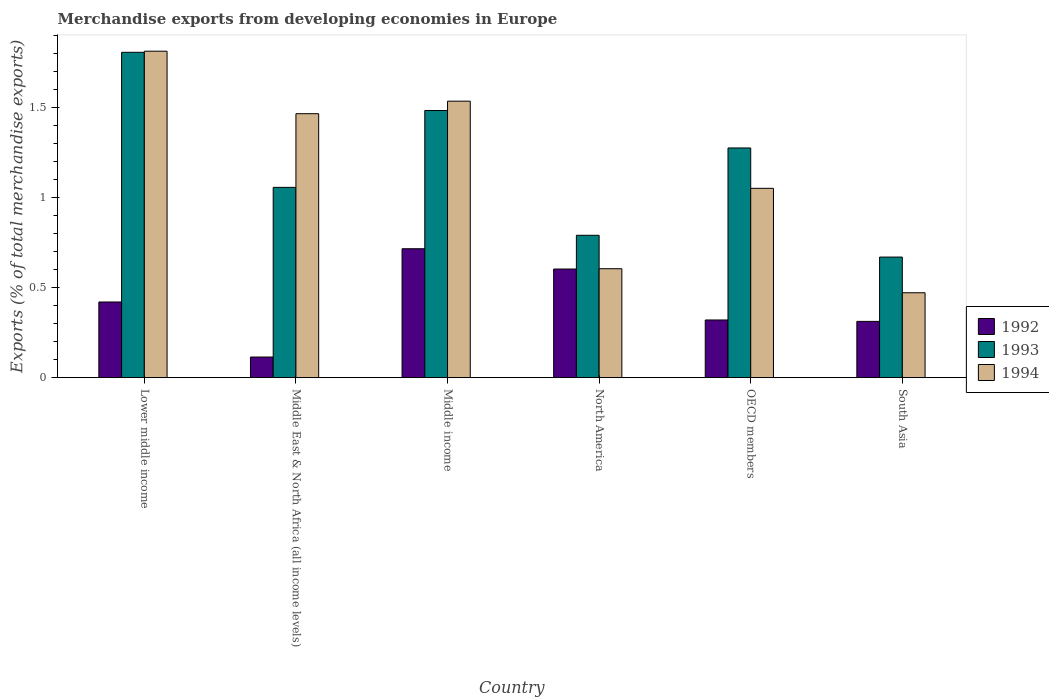How many different coloured bars are there?
Provide a short and direct response. 3. How many groups of bars are there?
Provide a succinct answer. 6. Are the number of bars on each tick of the X-axis equal?
Give a very brief answer. Yes. What is the percentage of total merchandise exports in 1992 in North America?
Make the answer very short. 0.6. Across all countries, what is the maximum percentage of total merchandise exports in 1993?
Ensure brevity in your answer.  1.81. Across all countries, what is the minimum percentage of total merchandise exports in 1993?
Provide a succinct answer. 0.67. In which country was the percentage of total merchandise exports in 1992 maximum?
Provide a short and direct response. Middle income. In which country was the percentage of total merchandise exports in 1992 minimum?
Your answer should be very brief. Middle East & North Africa (all income levels). What is the total percentage of total merchandise exports in 1993 in the graph?
Your response must be concise. 7.09. What is the difference between the percentage of total merchandise exports in 1994 in Lower middle income and that in South Asia?
Make the answer very short. 1.34. What is the difference between the percentage of total merchandise exports in 1993 in North America and the percentage of total merchandise exports in 1994 in OECD members?
Offer a terse response. -0.26. What is the average percentage of total merchandise exports in 1993 per country?
Your answer should be compact. 1.18. What is the difference between the percentage of total merchandise exports of/in 1994 and percentage of total merchandise exports of/in 1993 in OECD members?
Your answer should be compact. -0.22. In how many countries, is the percentage of total merchandise exports in 1992 greater than 1 %?
Your answer should be very brief. 0. What is the ratio of the percentage of total merchandise exports in 1994 in North America to that in OECD members?
Ensure brevity in your answer.  0.58. Is the difference between the percentage of total merchandise exports in 1994 in OECD members and South Asia greater than the difference between the percentage of total merchandise exports in 1993 in OECD members and South Asia?
Offer a terse response. No. What is the difference between the highest and the second highest percentage of total merchandise exports in 1993?
Offer a very short reply. 0.53. What is the difference between the highest and the lowest percentage of total merchandise exports in 1994?
Offer a terse response. 1.34. Is the sum of the percentage of total merchandise exports in 1992 in Middle East & North Africa (all income levels) and Middle income greater than the maximum percentage of total merchandise exports in 1993 across all countries?
Your answer should be compact. No. What does the 2nd bar from the right in Lower middle income represents?
Give a very brief answer. 1993. Is it the case that in every country, the sum of the percentage of total merchandise exports in 1994 and percentage of total merchandise exports in 1993 is greater than the percentage of total merchandise exports in 1992?
Provide a short and direct response. Yes. Are all the bars in the graph horizontal?
Your answer should be very brief. No. Are the values on the major ticks of Y-axis written in scientific E-notation?
Make the answer very short. No. Does the graph contain any zero values?
Your answer should be compact. No. What is the title of the graph?
Make the answer very short. Merchandise exports from developing economies in Europe. Does "1967" appear as one of the legend labels in the graph?
Give a very brief answer. No. What is the label or title of the Y-axis?
Offer a very short reply. Exports (% of total merchandise exports). What is the Exports (% of total merchandise exports) in 1992 in Lower middle income?
Offer a terse response. 0.42. What is the Exports (% of total merchandise exports) in 1993 in Lower middle income?
Your answer should be compact. 1.81. What is the Exports (% of total merchandise exports) in 1994 in Lower middle income?
Your response must be concise. 1.81. What is the Exports (% of total merchandise exports) of 1992 in Middle East & North Africa (all income levels)?
Offer a terse response. 0.11. What is the Exports (% of total merchandise exports) of 1993 in Middle East & North Africa (all income levels)?
Keep it short and to the point. 1.06. What is the Exports (% of total merchandise exports) in 1994 in Middle East & North Africa (all income levels)?
Provide a succinct answer. 1.47. What is the Exports (% of total merchandise exports) in 1992 in Middle income?
Offer a very short reply. 0.72. What is the Exports (% of total merchandise exports) of 1993 in Middle income?
Keep it short and to the point. 1.48. What is the Exports (% of total merchandise exports) of 1994 in Middle income?
Ensure brevity in your answer.  1.54. What is the Exports (% of total merchandise exports) in 1992 in North America?
Make the answer very short. 0.6. What is the Exports (% of total merchandise exports) in 1993 in North America?
Offer a very short reply. 0.79. What is the Exports (% of total merchandise exports) of 1994 in North America?
Provide a short and direct response. 0.61. What is the Exports (% of total merchandise exports) in 1992 in OECD members?
Give a very brief answer. 0.32. What is the Exports (% of total merchandise exports) of 1993 in OECD members?
Provide a short and direct response. 1.28. What is the Exports (% of total merchandise exports) in 1994 in OECD members?
Provide a short and direct response. 1.05. What is the Exports (% of total merchandise exports) of 1992 in South Asia?
Offer a very short reply. 0.31. What is the Exports (% of total merchandise exports) in 1993 in South Asia?
Your answer should be very brief. 0.67. What is the Exports (% of total merchandise exports) in 1994 in South Asia?
Offer a very short reply. 0.47. Across all countries, what is the maximum Exports (% of total merchandise exports) of 1992?
Make the answer very short. 0.72. Across all countries, what is the maximum Exports (% of total merchandise exports) of 1993?
Provide a short and direct response. 1.81. Across all countries, what is the maximum Exports (% of total merchandise exports) of 1994?
Your answer should be very brief. 1.81. Across all countries, what is the minimum Exports (% of total merchandise exports) in 1992?
Your answer should be compact. 0.11. Across all countries, what is the minimum Exports (% of total merchandise exports) in 1993?
Your answer should be very brief. 0.67. Across all countries, what is the minimum Exports (% of total merchandise exports) in 1994?
Provide a short and direct response. 0.47. What is the total Exports (% of total merchandise exports) of 1992 in the graph?
Provide a short and direct response. 2.49. What is the total Exports (% of total merchandise exports) of 1993 in the graph?
Offer a very short reply. 7.09. What is the total Exports (% of total merchandise exports) of 1994 in the graph?
Provide a short and direct response. 6.95. What is the difference between the Exports (% of total merchandise exports) of 1992 in Lower middle income and that in Middle East & North Africa (all income levels)?
Offer a very short reply. 0.31. What is the difference between the Exports (% of total merchandise exports) in 1993 in Lower middle income and that in Middle East & North Africa (all income levels)?
Give a very brief answer. 0.75. What is the difference between the Exports (% of total merchandise exports) of 1994 in Lower middle income and that in Middle East & North Africa (all income levels)?
Offer a very short reply. 0.35. What is the difference between the Exports (% of total merchandise exports) in 1992 in Lower middle income and that in Middle income?
Keep it short and to the point. -0.3. What is the difference between the Exports (% of total merchandise exports) of 1993 in Lower middle income and that in Middle income?
Provide a succinct answer. 0.32. What is the difference between the Exports (% of total merchandise exports) of 1994 in Lower middle income and that in Middle income?
Provide a short and direct response. 0.28. What is the difference between the Exports (% of total merchandise exports) in 1992 in Lower middle income and that in North America?
Your response must be concise. -0.18. What is the difference between the Exports (% of total merchandise exports) in 1993 in Lower middle income and that in North America?
Ensure brevity in your answer.  1.02. What is the difference between the Exports (% of total merchandise exports) of 1994 in Lower middle income and that in North America?
Ensure brevity in your answer.  1.21. What is the difference between the Exports (% of total merchandise exports) in 1992 in Lower middle income and that in OECD members?
Keep it short and to the point. 0.1. What is the difference between the Exports (% of total merchandise exports) of 1993 in Lower middle income and that in OECD members?
Keep it short and to the point. 0.53. What is the difference between the Exports (% of total merchandise exports) of 1994 in Lower middle income and that in OECD members?
Your answer should be very brief. 0.76. What is the difference between the Exports (% of total merchandise exports) in 1992 in Lower middle income and that in South Asia?
Provide a succinct answer. 0.11. What is the difference between the Exports (% of total merchandise exports) of 1993 in Lower middle income and that in South Asia?
Your answer should be very brief. 1.14. What is the difference between the Exports (% of total merchandise exports) in 1994 in Lower middle income and that in South Asia?
Offer a terse response. 1.34. What is the difference between the Exports (% of total merchandise exports) in 1992 in Middle East & North Africa (all income levels) and that in Middle income?
Ensure brevity in your answer.  -0.6. What is the difference between the Exports (% of total merchandise exports) in 1993 in Middle East & North Africa (all income levels) and that in Middle income?
Ensure brevity in your answer.  -0.43. What is the difference between the Exports (% of total merchandise exports) in 1994 in Middle East & North Africa (all income levels) and that in Middle income?
Provide a succinct answer. -0.07. What is the difference between the Exports (% of total merchandise exports) in 1992 in Middle East & North Africa (all income levels) and that in North America?
Your answer should be very brief. -0.49. What is the difference between the Exports (% of total merchandise exports) in 1993 in Middle East & North Africa (all income levels) and that in North America?
Provide a succinct answer. 0.27. What is the difference between the Exports (% of total merchandise exports) in 1994 in Middle East & North Africa (all income levels) and that in North America?
Your answer should be compact. 0.86. What is the difference between the Exports (% of total merchandise exports) of 1992 in Middle East & North Africa (all income levels) and that in OECD members?
Ensure brevity in your answer.  -0.21. What is the difference between the Exports (% of total merchandise exports) in 1993 in Middle East & North Africa (all income levels) and that in OECD members?
Offer a terse response. -0.22. What is the difference between the Exports (% of total merchandise exports) of 1994 in Middle East & North Africa (all income levels) and that in OECD members?
Offer a terse response. 0.41. What is the difference between the Exports (% of total merchandise exports) of 1992 in Middle East & North Africa (all income levels) and that in South Asia?
Keep it short and to the point. -0.2. What is the difference between the Exports (% of total merchandise exports) of 1993 in Middle East & North Africa (all income levels) and that in South Asia?
Provide a short and direct response. 0.39. What is the difference between the Exports (% of total merchandise exports) of 1994 in Middle East & North Africa (all income levels) and that in South Asia?
Offer a very short reply. 1. What is the difference between the Exports (% of total merchandise exports) in 1992 in Middle income and that in North America?
Ensure brevity in your answer.  0.11. What is the difference between the Exports (% of total merchandise exports) of 1993 in Middle income and that in North America?
Offer a terse response. 0.69. What is the difference between the Exports (% of total merchandise exports) of 1994 in Middle income and that in North America?
Provide a short and direct response. 0.93. What is the difference between the Exports (% of total merchandise exports) in 1992 in Middle income and that in OECD members?
Offer a terse response. 0.4. What is the difference between the Exports (% of total merchandise exports) in 1993 in Middle income and that in OECD members?
Make the answer very short. 0.21. What is the difference between the Exports (% of total merchandise exports) in 1994 in Middle income and that in OECD members?
Ensure brevity in your answer.  0.48. What is the difference between the Exports (% of total merchandise exports) of 1992 in Middle income and that in South Asia?
Keep it short and to the point. 0.4. What is the difference between the Exports (% of total merchandise exports) of 1993 in Middle income and that in South Asia?
Make the answer very short. 0.81. What is the difference between the Exports (% of total merchandise exports) in 1994 in Middle income and that in South Asia?
Provide a short and direct response. 1.06. What is the difference between the Exports (% of total merchandise exports) in 1992 in North America and that in OECD members?
Your answer should be compact. 0.28. What is the difference between the Exports (% of total merchandise exports) of 1993 in North America and that in OECD members?
Give a very brief answer. -0.49. What is the difference between the Exports (% of total merchandise exports) of 1994 in North America and that in OECD members?
Offer a terse response. -0.45. What is the difference between the Exports (% of total merchandise exports) in 1992 in North America and that in South Asia?
Your response must be concise. 0.29. What is the difference between the Exports (% of total merchandise exports) in 1993 in North America and that in South Asia?
Offer a terse response. 0.12. What is the difference between the Exports (% of total merchandise exports) in 1994 in North America and that in South Asia?
Your answer should be compact. 0.13. What is the difference between the Exports (% of total merchandise exports) of 1992 in OECD members and that in South Asia?
Provide a succinct answer. 0.01. What is the difference between the Exports (% of total merchandise exports) in 1993 in OECD members and that in South Asia?
Your response must be concise. 0.61. What is the difference between the Exports (% of total merchandise exports) of 1994 in OECD members and that in South Asia?
Offer a very short reply. 0.58. What is the difference between the Exports (% of total merchandise exports) in 1992 in Lower middle income and the Exports (% of total merchandise exports) in 1993 in Middle East & North Africa (all income levels)?
Provide a short and direct response. -0.64. What is the difference between the Exports (% of total merchandise exports) of 1992 in Lower middle income and the Exports (% of total merchandise exports) of 1994 in Middle East & North Africa (all income levels)?
Provide a short and direct response. -1.05. What is the difference between the Exports (% of total merchandise exports) of 1993 in Lower middle income and the Exports (% of total merchandise exports) of 1994 in Middle East & North Africa (all income levels)?
Your response must be concise. 0.34. What is the difference between the Exports (% of total merchandise exports) of 1992 in Lower middle income and the Exports (% of total merchandise exports) of 1993 in Middle income?
Make the answer very short. -1.06. What is the difference between the Exports (% of total merchandise exports) of 1992 in Lower middle income and the Exports (% of total merchandise exports) of 1994 in Middle income?
Ensure brevity in your answer.  -1.12. What is the difference between the Exports (% of total merchandise exports) in 1993 in Lower middle income and the Exports (% of total merchandise exports) in 1994 in Middle income?
Offer a terse response. 0.27. What is the difference between the Exports (% of total merchandise exports) of 1992 in Lower middle income and the Exports (% of total merchandise exports) of 1993 in North America?
Keep it short and to the point. -0.37. What is the difference between the Exports (% of total merchandise exports) in 1992 in Lower middle income and the Exports (% of total merchandise exports) in 1994 in North America?
Your answer should be compact. -0.18. What is the difference between the Exports (% of total merchandise exports) in 1993 in Lower middle income and the Exports (% of total merchandise exports) in 1994 in North America?
Make the answer very short. 1.2. What is the difference between the Exports (% of total merchandise exports) of 1992 in Lower middle income and the Exports (% of total merchandise exports) of 1993 in OECD members?
Keep it short and to the point. -0.86. What is the difference between the Exports (% of total merchandise exports) of 1992 in Lower middle income and the Exports (% of total merchandise exports) of 1994 in OECD members?
Give a very brief answer. -0.63. What is the difference between the Exports (% of total merchandise exports) of 1993 in Lower middle income and the Exports (% of total merchandise exports) of 1994 in OECD members?
Offer a terse response. 0.76. What is the difference between the Exports (% of total merchandise exports) of 1992 in Lower middle income and the Exports (% of total merchandise exports) of 1993 in South Asia?
Make the answer very short. -0.25. What is the difference between the Exports (% of total merchandise exports) of 1992 in Lower middle income and the Exports (% of total merchandise exports) of 1994 in South Asia?
Provide a succinct answer. -0.05. What is the difference between the Exports (% of total merchandise exports) in 1993 in Lower middle income and the Exports (% of total merchandise exports) in 1994 in South Asia?
Keep it short and to the point. 1.34. What is the difference between the Exports (% of total merchandise exports) of 1992 in Middle East & North Africa (all income levels) and the Exports (% of total merchandise exports) of 1993 in Middle income?
Your answer should be compact. -1.37. What is the difference between the Exports (% of total merchandise exports) of 1992 in Middle East & North Africa (all income levels) and the Exports (% of total merchandise exports) of 1994 in Middle income?
Offer a very short reply. -1.42. What is the difference between the Exports (% of total merchandise exports) in 1993 in Middle East & North Africa (all income levels) and the Exports (% of total merchandise exports) in 1994 in Middle income?
Offer a terse response. -0.48. What is the difference between the Exports (% of total merchandise exports) of 1992 in Middle East & North Africa (all income levels) and the Exports (% of total merchandise exports) of 1993 in North America?
Give a very brief answer. -0.68. What is the difference between the Exports (% of total merchandise exports) in 1992 in Middle East & North Africa (all income levels) and the Exports (% of total merchandise exports) in 1994 in North America?
Offer a very short reply. -0.49. What is the difference between the Exports (% of total merchandise exports) in 1993 in Middle East & North Africa (all income levels) and the Exports (% of total merchandise exports) in 1994 in North America?
Your answer should be very brief. 0.45. What is the difference between the Exports (% of total merchandise exports) of 1992 in Middle East & North Africa (all income levels) and the Exports (% of total merchandise exports) of 1993 in OECD members?
Offer a terse response. -1.16. What is the difference between the Exports (% of total merchandise exports) of 1992 in Middle East & North Africa (all income levels) and the Exports (% of total merchandise exports) of 1994 in OECD members?
Give a very brief answer. -0.94. What is the difference between the Exports (% of total merchandise exports) in 1993 in Middle East & North Africa (all income levels) and the Exports (% of total merchandise exports) in 1994 in OECD members?
Your response must be concise. 0.01. What is the difference between the Exports (% of total merchandise exports) of 1992 in Middle East & North Africa (all income levels) and the Exports (% of total merchandise exports) of 1993 in South Asia?
Offer a very short reply. -0.56. What is the difference between the Exports (% of total merchandise exports) of 1992 in Middle East & North Africa (all income levels) and the Exports (% of total merchandise exports) of 1994 in South Asia?
Keep it short and to the point. -0.36. What is the difference between the Exports (% of total merchandise exports) in 1993 in Middle East & North Africa (all income levels) and the Exports (% of total merchandise exports) in 1994 in South Asia?
Give a very brief answer. 0.59. What is the difference between the Exports (% of total merchandise exports) of 1992 in Middle income and the Exports (% of total merchandise exports) of 1993 in North America?
Your answer should be compact. -0.07. What is the difference between the Exports (% of total merchandise exports) of 1992 in Middle income and the Exports (% of total merchandise exports) of 1994 in North America?
Your response must be concise. 0.11. What is the difference between the Exports (% of total merchandise exports) in 1993 in Middle income and the Exports (% of total merchandise exports) in 1994 in North America?
Provide a short and direct response. 0.88. What is the difference between the Exports (% of total merchandise exports) of 1992 in Middle income and the Exports (% of total merchandise exports) of 1993 in OECD members?
Keep it short and to the point. -0.56. What is the difference between the Exports (% of total merchandise exports) of 1992 in Middle income and the Exports (% of total merchandise exports) of 1994 in OECD members?
Ensure brevity in your answer.  -0.34. What is the difference between the Exports (% of total merchandise exports) of 1993 in Middle income and the Exports (% of total merchandise exports) of 1994 in OECD members?
Give a very brief answer. 0.43. What is the difference between the Exports (% of total merchandise exports) of 1992 in Middle income and the Exports (% of total merchandise exports) of 1993 in South Asia?
Your answer should be compact. 0.05. What is the difference between the Exports (% of total merchandise exports) of 1992 in Middle income and the Exports (% of total merchandise exports) of 1994 in South Asia?
Keep it short and to the point. 0.24. What is the difference between the Exports (% of total merchandise exports) of 1993 in Middle income and the Exports (% of total merchandise exports) of 1994 in South Asia?
Make the answer very short. 1.01. What is the difference between the Exports (% of total merchandise exports) of 1992 in North America and the Exports (% of total merchandise exports) of 1993 in OECD members?
Your answer should be compact. -0.67. What is the difference between the Exports (% of total merchandise exports) in 1992 in North America and the Exports (% of total merchandise exports) in 1994 in OECD members?
Ensure brevity in your answer.  -0.45. What is the difference between the Exports (% of total merchandise exports) in 1993 in North America and the Exports (% of total merchandise exports) in 1994 in OECD members?
Provide a short and direct response. -0.26. What is the difference between the Exports (% of total merchandise exports) of 1992 in North America and the Exports (% of total merchandise exports) of 1993 in South Asia?
Your answer should be very brief. -0.07. What is the difference between the Exports (% of total merchandise exports) in 1992 in North America and the Exports (% of total merchandise exports) in 1994 in South Asia?
Offer a very short reply. 0.13. What is the difference between the Exports (% of total merchandise exports) of 1993 in North America and the Exports (% of total merchandise exports) of 1994 in South Asia?
Give a very brief answer. 0.32. What is the difference between the Exports (% of total merchandise exports) of 1992 in OECD members and the Exports (% of total merchandise exports) of 1993 in South Asia?
Keep it short and to the point. -0.35. What is the difference between the Exports (% of total merchandise exports) of 1992 in OECD members and the Exports (% of total merchandise exports) of 1994 in South Asia?
Provide a succinct answer. -0.15. What is the difference between the Exports (% of total merchandise exports) in 1993 in OECD members and the Exports (% of total merchandise exports) in 1994 in South Asia?
Your answer should be compact. 0.8. What is the average Exports (% of total merchandise exports) in 1992 per country?
Give a very brief answer. 0.41. What is the average Exports (% of total merchandise exports) in 1993 per country?
Keep it short and to the point. 1.18. What is the average Exports (% of total merchandise exports) in 1994 per country?
Your answer should be compact. 1.16. What is the difference between the Exports (% of total merchandise exports) in 1992 and Exports (% of total merchandise exports) in 1993 in Lower middle income?
Offer a terse response. -1.39. What is the difference between the Exports (% of total merchandise exports) of 1992 and Exports (% of total merchandise exports) of 1994 in Lower middle income?
Keep it short and to the point. -1.39. What is the difference between the Exports (% of total merchandise exports) of 1993 and Exports (% of total merchandise exports) of 1994 in Lower middle income?
Keep it short and to the point. -0.01. What is the difference between the Exports (% of total merchandise exports) in 1992 and Exports (% of total merchandise exports) in 1993 in Middle East & North Africa (all income levels)?
Give a very brief answer. -0.94. What is the difference between the Exports (% of total merchandise exports) in 1992 and Exports (% of total merchandise exports) in 1994 in Middle East & North Africa (all income levels)?
Keep it short and to the point. -1.35. What is the difference between the Exports (% of total merchandise exports) in 1993 and Exports (% of total merchandise exports) in 1994 in Middle East & North Africa (all income levels)?
Ensure brevity in your answer.  -0.41. What is the difference between the Exports (% of total merchandise exports) of 1992 and Exports (% of total merchandise exports) of 1993 in Middle income?
Your answer should be compact. -0.77. What is the difference between the Exports (% of total merchandise exports) in 1992 and Exports (% of total merchandise exports) in 1994 in Middle income?
Keep it short and to the point. -0.82. What is the difference between the Exports (% of total merchandise exports) in 1993 and Exports (% of total merchandise exports) in 1994 in Middle income?
Ensure brevity in your answer.  -0.05. What is the difference between the Exports (% of total merchandise exports) in 1992 and Exports (% of total merchandise exports) in 1993 in North America?
Offer a very short reply. -0.19. What is the difference between the Exports (% of total merchandise exports) in 1992 and Exports (% of total merchandise exports) in 1994 in North America?
Offer a very short reply. -0. What is the difference between the Exports (% of total merchandise exports) of 1993 and Exports (% of total merchandise exports) of 1994 in North America?
Your answer should be very brief. 0.19. What is the difference between the Exports (% of total merchandise exports) of 1992 and Exports (% of total merchandise exports) of 1993 in OECD members?
Give a very brief answer. -0.96. What is the difference between the Exports (% of total merchandise exports) in 1992 and Exports (% of total merchandise exports) in 1994 in OECD members?
Offer a very short reply. -0.73. What is the difference between the Exports (% of total merchandise exports) of 1993 and Exports (% of total merchandise exports) of 1994 in OECD members?
Offer a very short reply. 0.22. What is the difference between the Exports (% of total merchandise exports) in 1992 and Exports (% of total merchandise exports) in 1993 in South Asia?
Ensure brevity in your answer.  -0.36. What is the difference between the Exports (% of total merchandise exports) in 1992 and Exports (% of total merchandise exports) in 1994 in South Asia?
Give a very brief answer. -0.16. What is the difference between the Exports (% of total merchandise exports) of 1993 and Exports (% of total merchandise exports) of 1994 in South Asia?
Your answer should be compact. 0.2. What is the ratio of the Exports (% of total merchandise exports) of 1992 in Lower middle income to that in Middle East & North Africa (all income levels)?
Your answer should be very brief. 3.67. What is the ratio of the Exports (% of total merchandise exports) in 1993 in Lower middle income to that in Middle East & North Africa (all income levels)?
Offer a very short reply. 1.71. What is the ratio of the Exports (% of total merchandise exports) of 1994 in Lower middle income to that in Middle East & North Africa (all income levels)?
Offer a terse response. 1.24. What is the ratio of the Exports (% of total merchandise exports) in 1992 in Lower middle income to that in Middle income?
Your response must be concise. 0.59. What is the ratio of the Exports (% of total merchandise exports) in 1993 in Lower middle income to that in Middle income?
Your answer should be very brief. 1.22. What is the ratio of the Exports (% of total merchandise exports) of 1994 in Lower middle income to that in Middle income?
Give a very brief answer. 1.18. What is the ratio of the Exports (% of total merchandise exports) in 1992 in Lower middle income to that in North America?
Provide a succinct answer. 0.7. What is the ratio of the Exports (% of total merchandise exports) in 1993 in Lower middle income to that in North America?
Offer a terse response. 2.29. What is the ratio of the Exports (% of total merchandise exports) in 1994 in Lower middle income to that in North America?
Provide a succinct answer. 3. What is the ratio of the Exports (% of total merchandise exports) in 1992 in Lower middle income to that in OECD members?
Ensure brevity in your answer.  1.31. What is the ratio of the Exports (% of total merchandise exports) in 1993 in Lower middle income to that in OECD members?
Your response must be concise. 1.42. What is the ratio of the Exports (% of total merchandise exports) of 1994 in Lower middle income to that in OECD members?
Make the answer very short. 1.72. What is the ratio of the Exports (% of total merchandise exports) of 1992 in Lower middle income to that in South Asia?
Keep it short and to the point. 1.34. What is the ratio of the Exports (% of total merchandise exports) in 1993 in Lower middle income to that in South Asia?
Offer a very short reply. 2.7. What is the ratio of the Exports (% of total merchandise exports) of 1994 in Lower middle income to that in South Asia?
Offer a terse response. 3.85. What is the ratio of the Exports (% of total merchandise exports) in 1992 in Middle East & North Africa (all income levels) to that in Middle income?
Make the answer very short. 0.16. What is the ratio of the Exports (% of total merchandise exports) of 1993 in Middle East & North Africa (all income levels) to that in Middle income?
Make the answer very short. 0.71. What is the ratio of the Exports (% of total merchandise exports) in 1994 in Middle East & North Africa (all income levels) to that in Middle income?
Provide a short and direct response. 0.95. What is the ratio of the Exports (% of total merchandise exports) of 1992 in Middle East & North Africa (all income levels) to that in North America?
Keep it short and to the point. 0.19. What is the ratio of the Exports (% of total merchandise exports) of 1993 in Middle East & North Africa (all income levels) to that in North America?
Offer a terse response. 1.34. What is the ratio of the Exports (% of total merchandise exports) in 1994 in Middle East & North Africa (all income levels) to that in North America?
Ensure brevity in your answer.  2.42. What is the ratio of the Exports (% of total merchandise exports) in 1992 in Middle East & North Africa (all income levels) to that in OECD members?
Your answer should be compact. 0.36. What is the ratio of the Exports (% of total merchandise exports) in 1993 in Middle East & North Africa (all income levels) to that in OECD members?
Your response must be concise. 0.83. What is the ratio of the Exports (% of total merchandise exports) in 1994 in Middle East & North Africa (all income levels) to that in OECD members?
Give a very brief answer. 1.39. What is the ratio of the Exports (% of total merchandise exports) in 1992 in Middle East & North Africa (all income levels) to that in South Asia?
Offer a terse response. 0.37. What is the ratio of the Exports (% of total merchandise exports) of 1993 in Middle East & North Africa (all income levels) to that in South Asia?
Keep it short and to the point. 1.58. What is the ratio of the Exports (% of total merchandise exports) in 1994 in Middle East & North Africa (all income levels) to that in South Asia?
Your response must be concise. 3.11. What is the ratio of the Exports (% of total merchandise exports) in 1992 in Middle income to that in North America?
Your answer should be compact. 1.19. What is the ratio of the Exports (% of total merchandise exports) in 1993 in Middle income to that in North America?
Your answer should be very brief. 1.88. What is the ratio of the Exports (% of total merchandise exports) in 1994 in Middle income to that in North America?
Give a very brief answer. 2.54. What is the ratio of the Exports (% of total merchandise exports) of 1992 in Middle income to that in OECD members?
Ensure brevity in your answer.  2.23. What is the ratio of the Exports (% of total merchandise exports) of 1993 in Middle income to that in OECD members?
Give a very brief answer. 1.16. What is the ratio of the Exports (% of total merchandise exports) in 1994 in Middle income to that in OECD members?
Your answer should be compact. 1.46. What is the ratio of the Exports (% of total merchandise exports) in 1992 in Middle income to that in South Asia?
Provide a short and direct response. 2.29. What is the ratio of the Exports (% of total merchandise exports) of 1993 in Middle income to that in South Asia?
Your answer should be very brief. 2.22. What is the ratio of the Exports (% of total merchandise exports) of 1994 in Middle income to that in South Asia?
Make the answer very short. 3.26. What is the ratio of the Exports (% of total merchandise exports) in 1992 in North America to that in OECD members?
Give a very brief answer. 1.88. What is the ratio of the Exports (% of total merchandise exports) of 1993 in North America to that in OECD members?
Provide a short and direct response. 0.62. What is the ratio of the Exports (% of total merchandise exports) of 1994 in North America to that in OECD members?
Make the answer very short. 0.58. What is the ratio of the Exports (% of total merchandise exports) of 1992 in North America to that in South Asia?
Your answer should be very brief. 1.93. What is the ratio of the Exports (% of total merchandise exports) of 1993 in North America to that in South Asia?
Keep it short and to the point. 1.18. What is the ratio of the Exports (% of total merchandise exports) in 1994 in North America to that in South Asia?
Your answer should be compact. 1.28. What is the ratio of the Exports (% of total merchandise exports) in 1992 in OECD members to that in South Asia?
Keep it short and to the point. 1.03. What is the ratio of the Exports (% of total merchandise exports) of 1993 in OECD members to that in South Asia?
Your response must be concise. 1.9. What is the ratio of the Exports (% of total merchandise exports) in 1994 in OECD members to that in South Asia?
Provide a short and direct response. 2.23. What is the difference between the highest and the second highest Exports (% of total merchandise exports) in 1992?
Give a very brief answer. 0.11. What is the difference between the highest and the second highest Exports (% of total merchandise exports) in 1993?
Your answer should be very brief. 0.32. What is the difference between the highest and the second highest Exports (% of total merchandise exports) of 1994?
Give a very brief answer. 0.28. What is the difference between the highest and the lowest Exports (% of total merchandise exports) in 1992?
Give a very brief answer. 0.6. What is the difference between the highest and the lowest Exports (% of total merchandise exports) in 1993?
Keep it short and to the point. 1.14. What is the difference between the highest and the lowest Exports (% of total merchandise exports) in 1994?
Offer a terse response. 1.34. 